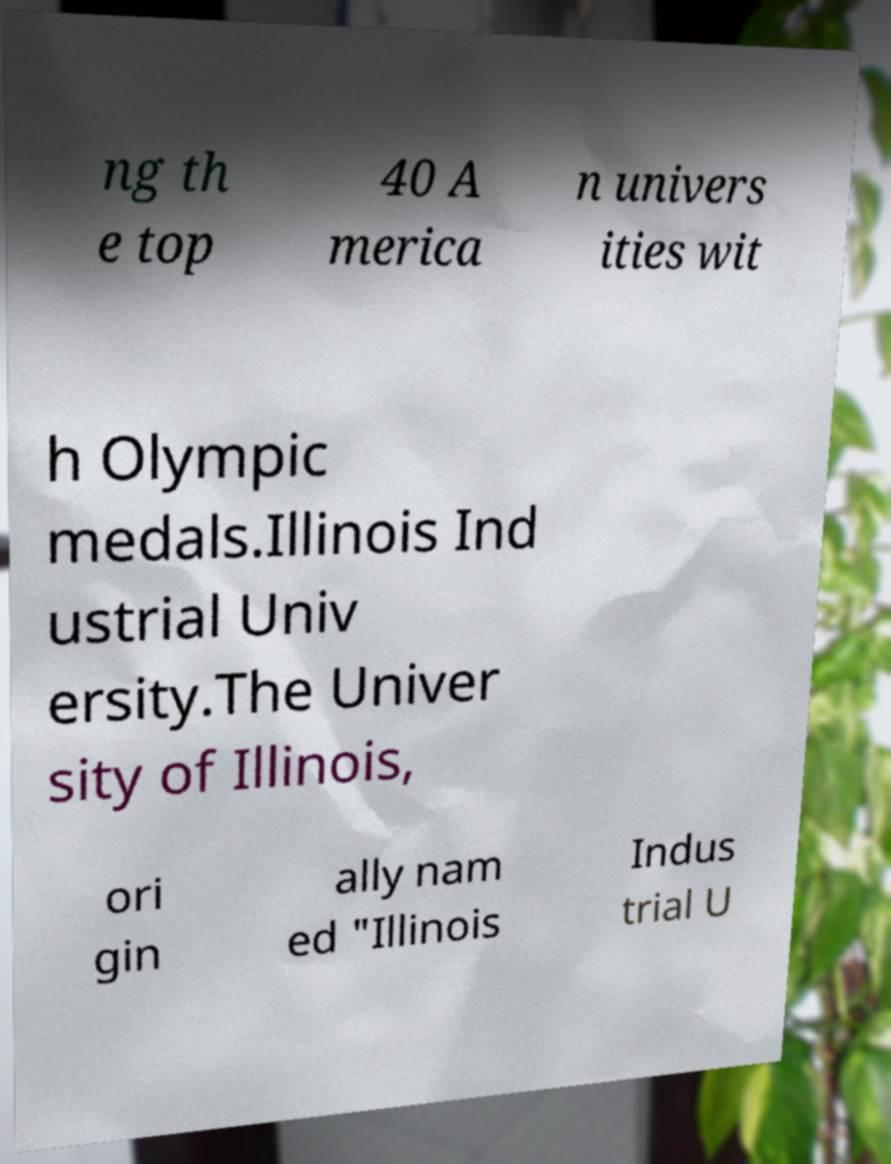Could you assist in decoding the text presented in this image and type it out clearly? ng th e top 40 A merica n univers ities wit h Olympic medals.Illinois Ind ustrial Univ ersity.The Univer sity of Illinois, ori gin ally nam ed "Illinois Indus trial U 